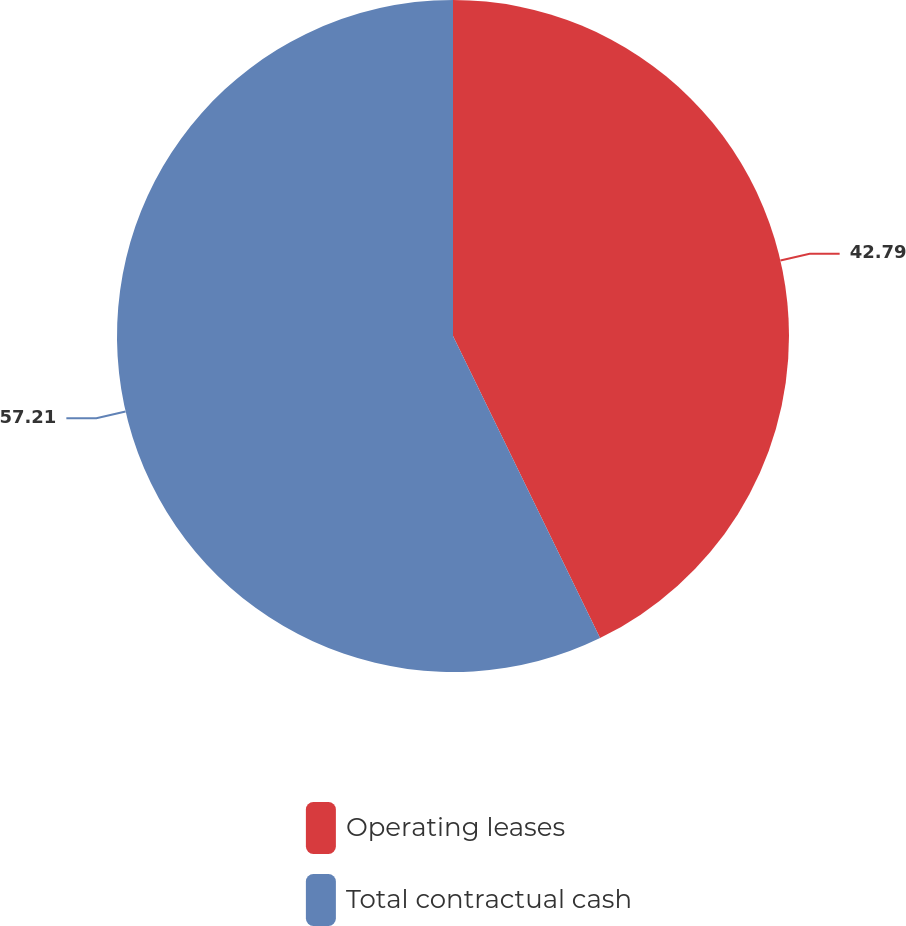<chart> <loc_0><loc_0><loc_500><loc_500><pie_chart><fcel>Operating leases<fcel>Total contractual cash<nl><fcel>42.79%<fcel>57.21%<nl></chart> 